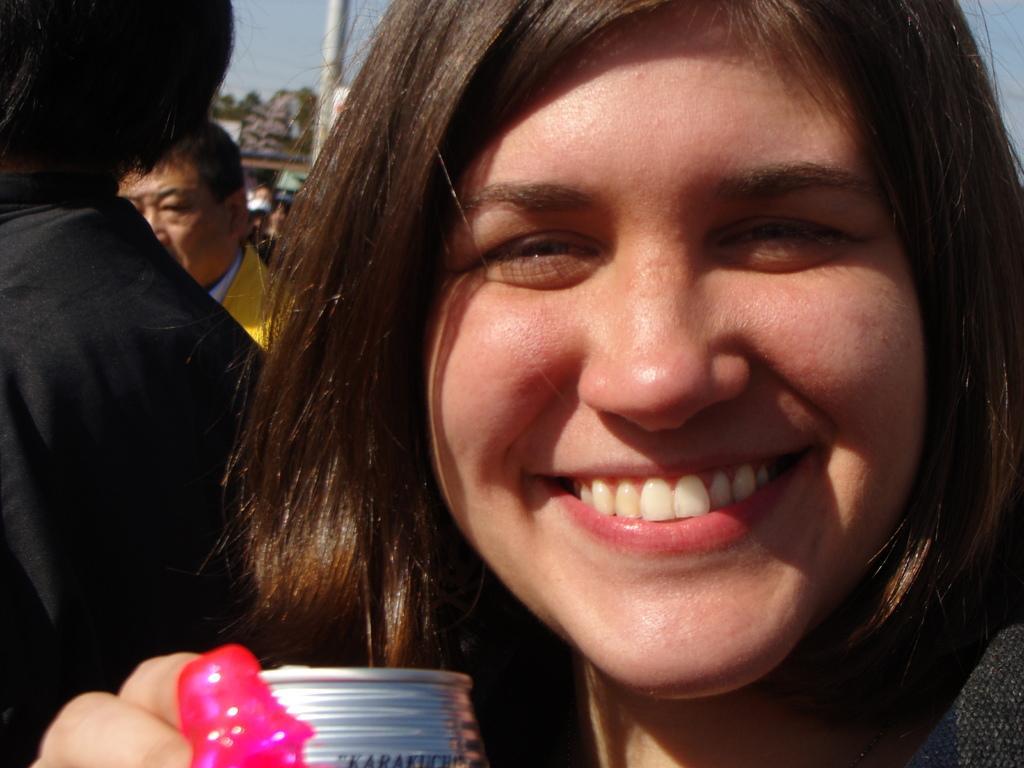How would you summarize this image in a sentence or two? In the image there is a woman in the foreground, she is laughing and behind her there are few other people. 